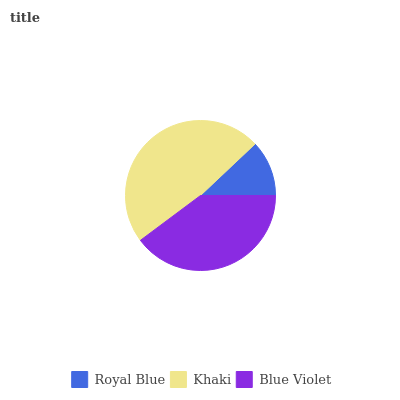Is Royal Blue the minimum?
Answer yes or no. Yes. Is Khaki the maximum?
Answer yes or no. Yes. Is Blue Violet the minimum?
Answer yes or no. No. Is Blue Violet the maximum?
Answer yes or no. No. Is Khaki greater than Blue Violet?
Answer yes or no. Yes. Is Blue Violet less than Khaki?
Answer yes or no. Yes. Is Blue Violet greater than Khaki?
Answer yes or no. No. Is Khaki less than Blue Violet?
Answer yes or no. No. Is Blue Violet the high median?
Answer yes or no. Yes. Is Blue Violet the low median?
Answer yes or no. Yes. Is Royal Blue the high median?
Answer yes or no. No. Is Khaki the low median?
Answer yes or no. No. 